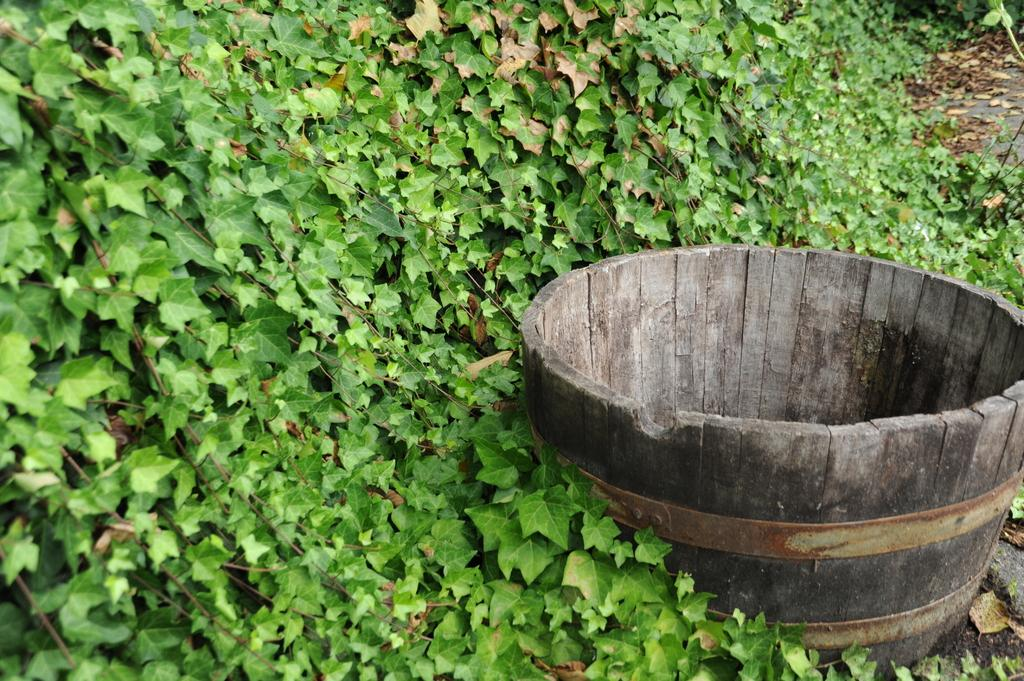What type of container is present in the picture? There is a wooden barrel in the picture. What other elements can be seen in the image? There are plants in the picture. How much salt is present in the wooden barrel in the image? There is no salt present in the wooden barrel in the image, as it is a container for plants. 